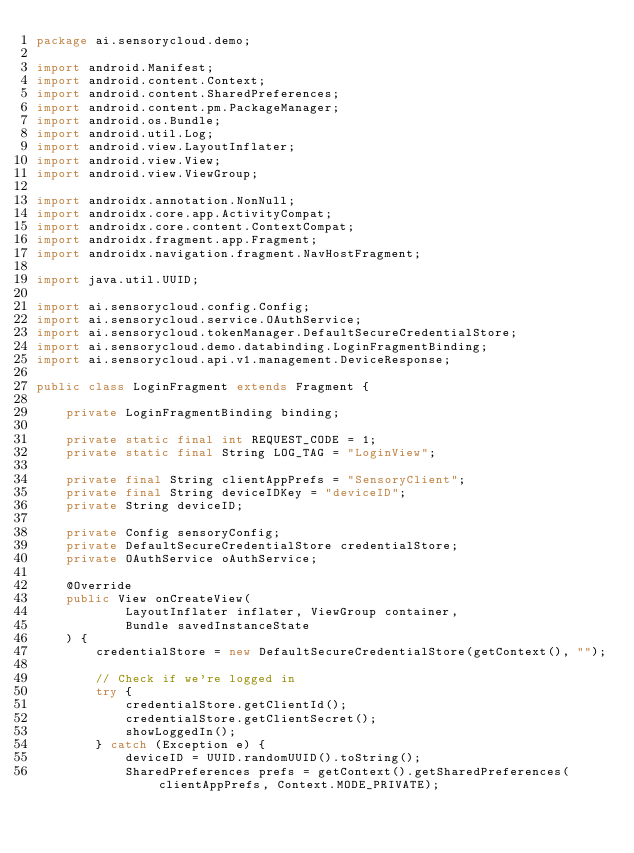Convert code to text. <code><loc_0><loc_0><loc_500><loc_500><_Java_>package ai.sensorycloud.demo;

import android.Manifest;
import android.content.Context;
import android.content.SharedPreferences;
import android.content.pm.PackageManager;
import android.os.Bundle;
import android.util.Log;
import android.view.LayoutInflater;
import android.view.View;
import android.view.ViewGroup;

import androidx.annotation.NonNull;
import androidx.core.app.ActivityCompat;
import androidx.core.content.ContextCompat;
import androidx.fragment.app.Fragment;
import androidx.navigation.fragment.NavHostFragment;

import java.util.UUID;

import ai.sensorycloud.config.Config;
import ai.sensorycloud.service.OAuthService;
import ai.sensorycloud.tokenManager.DefaultSecureCredentialStore;
import ai.sensorycloud.demo.databinding.LoginFragmentBinding;
import ai.sensorycloud.api.v1.management.DeviceResponse;

public class LoginFragment extends Fragment {

    private LoginFragmentBinding binding;

    private static final int REQUEST_CODE = 1;
    private static final String LOG_TAG = "LoginView";

    private final String clientAppPrefs = "SensoryClient";
    private final String deviceIDKey = "deviceID";
    private String deviceID;

    private Config sensoryConfig;
    private DefaultSecureCredentialStore credentialStore;
    private OAuthService oAuthService;

    @Override
    public View onCreateView(
            LayoutInflater inflater, ViewGroup container,
            Bundle savedInstanceState
    ) {
        credentialStore = new DefaultSecureCredentialStore(getContext(), "");

        // Check if we're logged in
        try {
            credentialStore.getClientId();
            credentialStore.getClientSecret();
            showLoggedIn();
        } catch (Exception e) {
            deviceID = UUID.randomUUID().toString();
            SharedPreferences prefs = getContext().getSharedPreferences(clientAppPrefs, Context.MODE_PRIVATE);</code> 